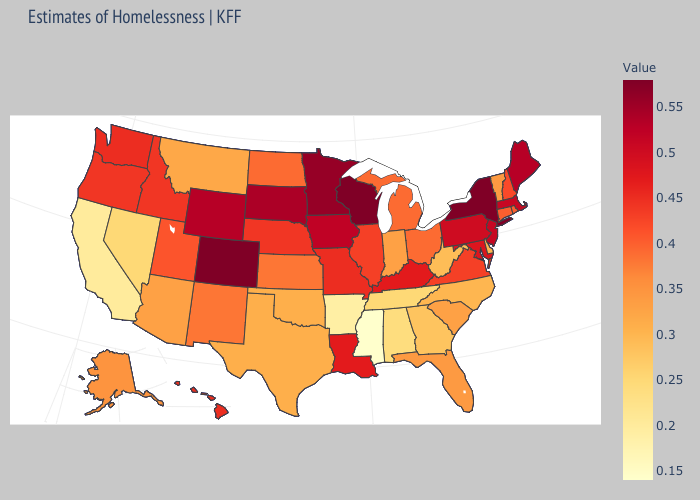Does Massachusetts have a higher value than Wisconsin?
Short answer required. No. Does the map have missing data?
Quick response, please. No. Which states hav the highest value in the Northeast?
Answer briefly. New York. 